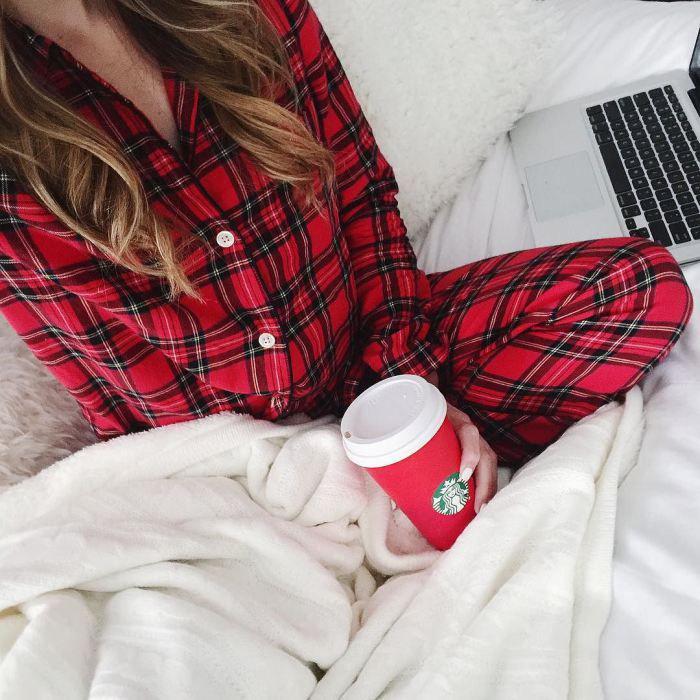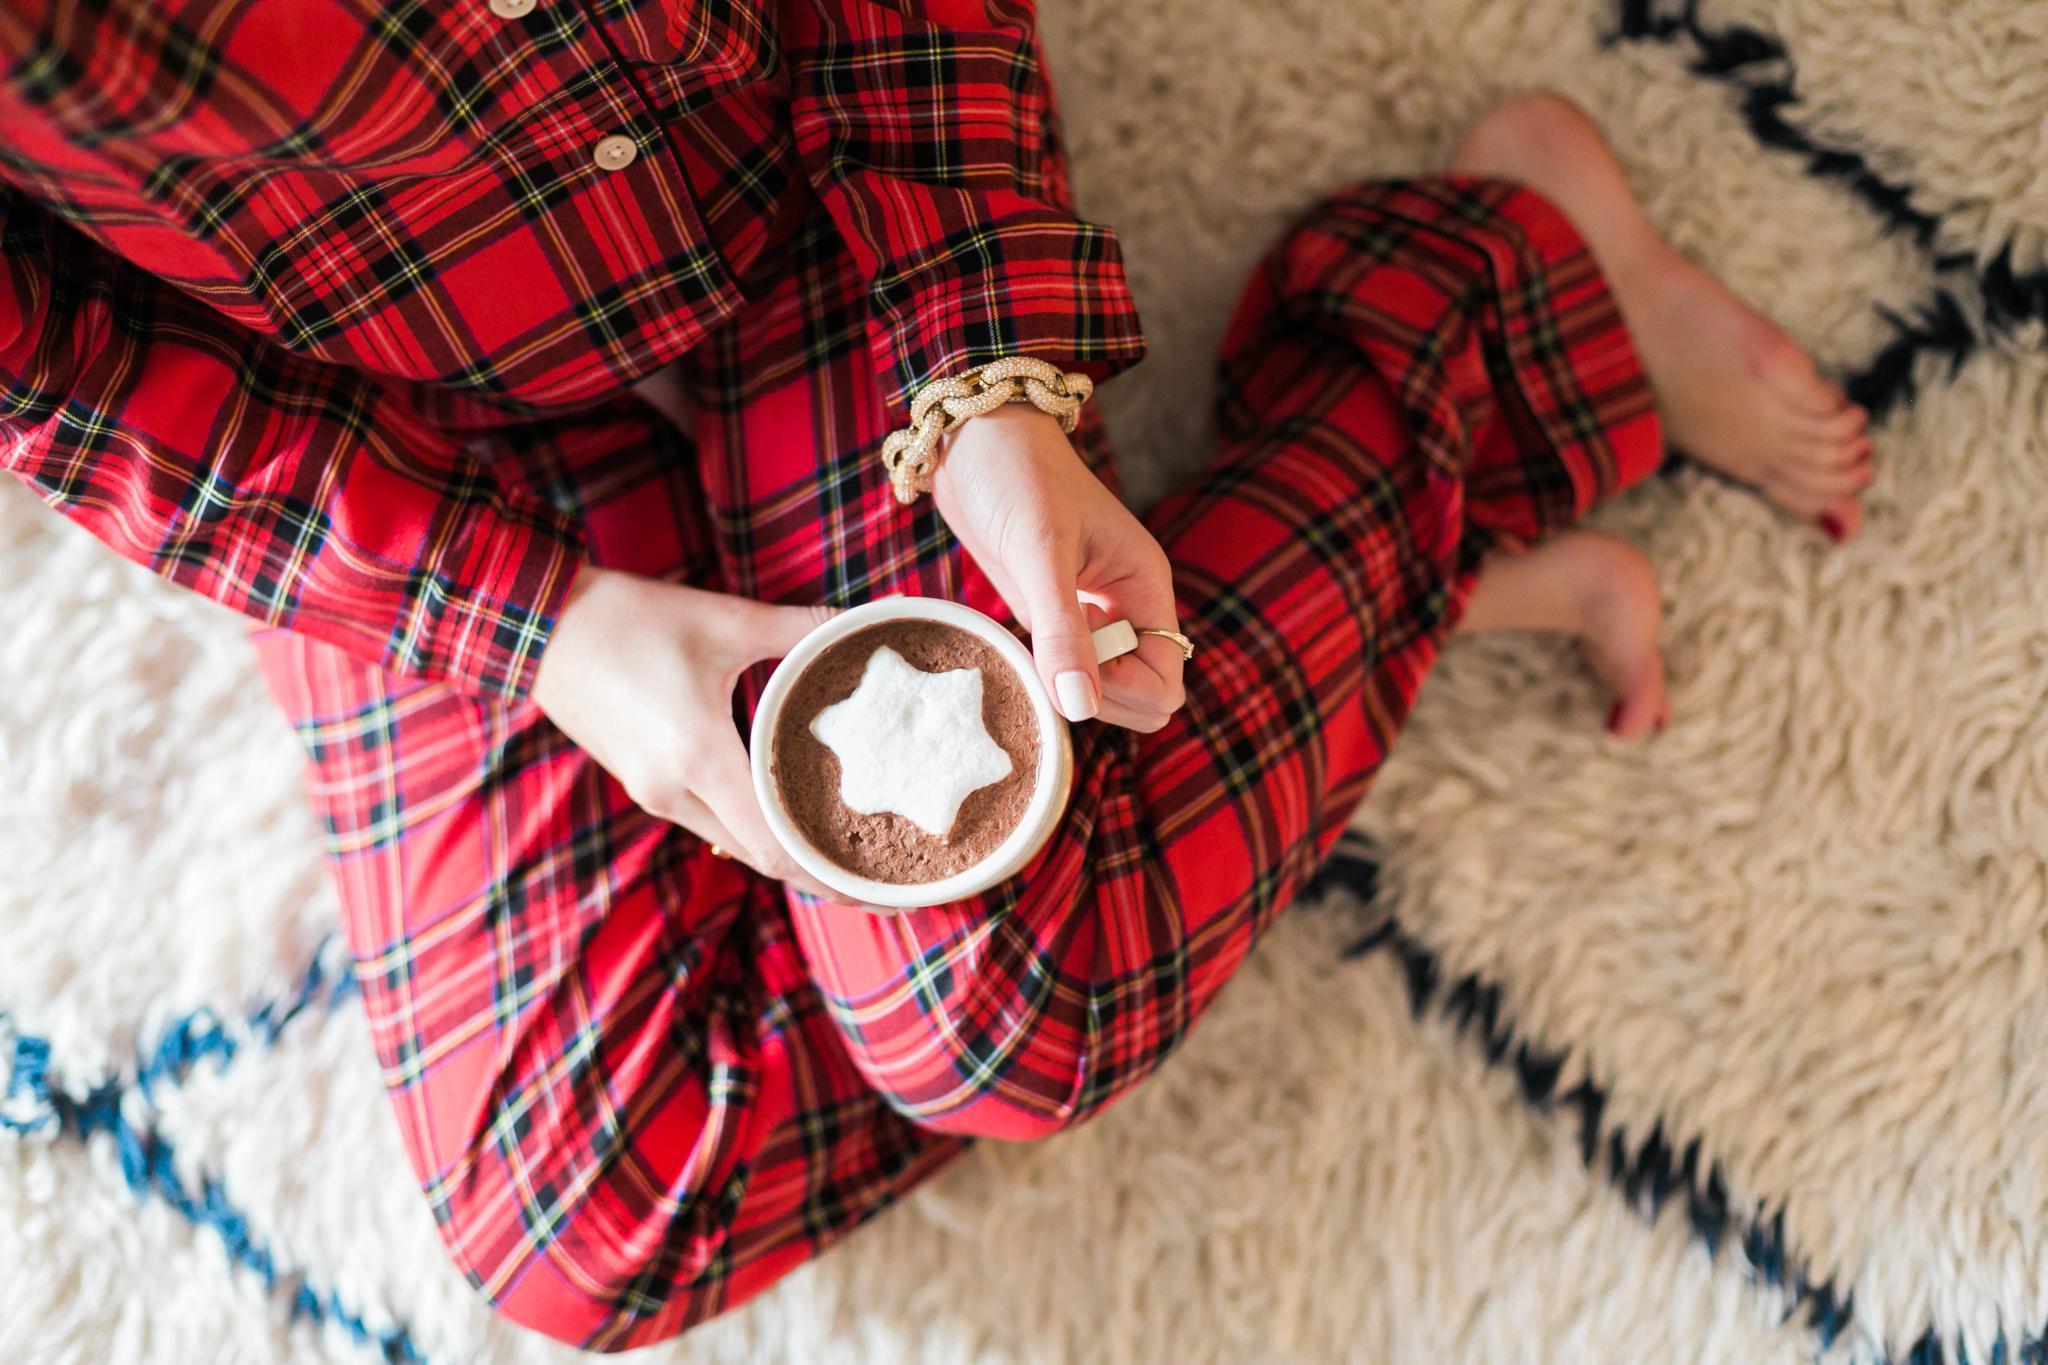The first image is the image on the left, the second image is the image on the right. Considering the images on both sides, is "The right image contains at least one person dressed in sleep attire." valid? Answer yes or no. Yes. The first image is the image on the left, the second image is the image on the right. Assess this claim about the two images: "At least one pair of pajamas in both images feature a plaid bottom.". Correct or not? Answer yes or no. Yes. 